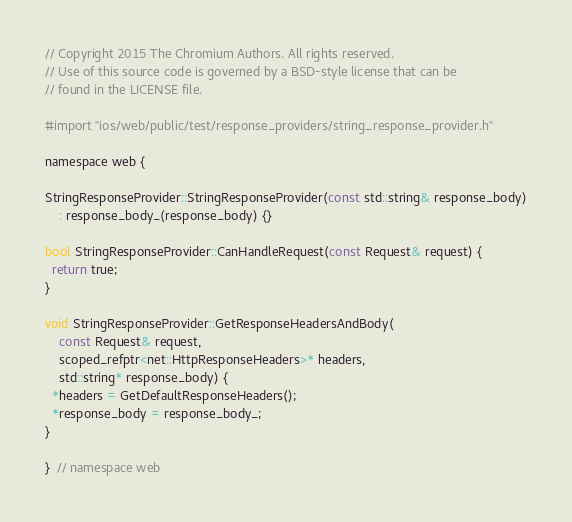<code> <loc_0><loc_0><loc_500><loc_500><_ObjectiveC_>// Copyright 2015 The Chromium Authors. All rights reserved.
// Use of this source code is governed by a BSD-style license that can be
// found in the LICENSE file.

#import "ios/web/public/test/response_providers/string_response_provider.h"

namespace web {

StringResponseProvider::StringResponseProvider(const std::string& response_body)
    : response_body_(response_body) {}

bool StringResponseProvider::CanHandleRequest(const Request& request) {
  return true;
}

void StringResponseProvider::GetResponseHeadersAndBody(
    const Request& request,
    scoped_refptr<net::HttpResponseHeaders>* headers,
    std::string* response_body) {
  *headers = GetDefaultResponseHeaders();
  *response_body = response_body_;
}

}  // namespace web
</code> 